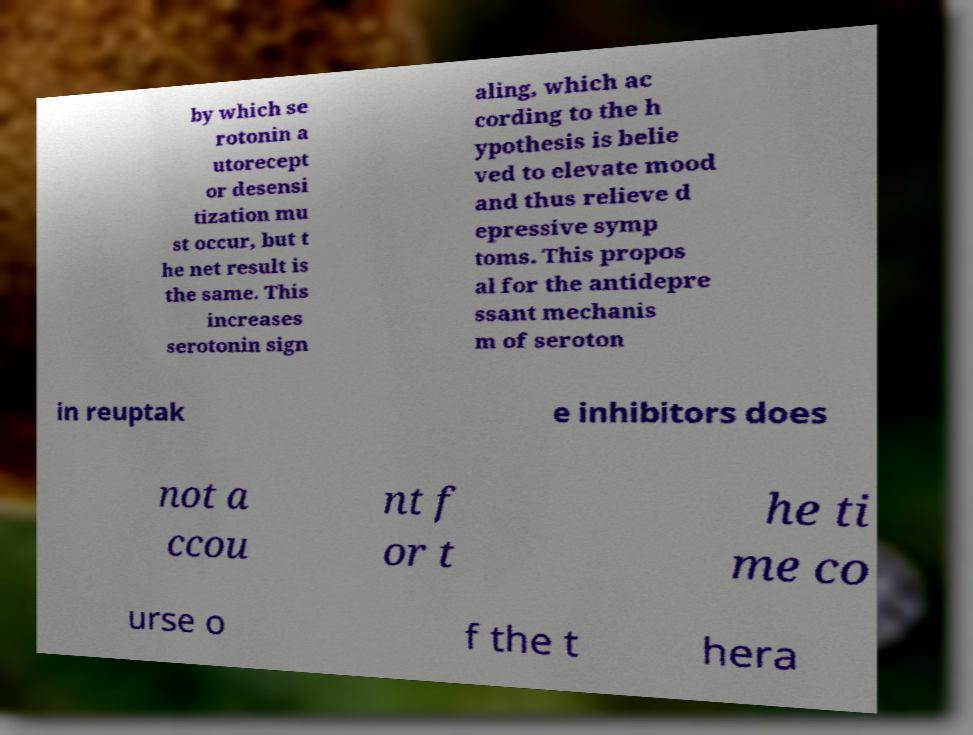For documentation purposes, I need the text within this image transcribed. Could you provide that? by which se rotonin a utorecept or desensi tization mu st occur, but t he net result is the same. This increases serotonin sign aling, which ac cording to the h ypothesis is belie ved to elevate mood and thus relieve d epressive symp toms. This propos al for the antidepre ssant mechanis m of seroton in reuptak e inhibitors does not a ccou nt f or t he ti me co urse o f the t hera 